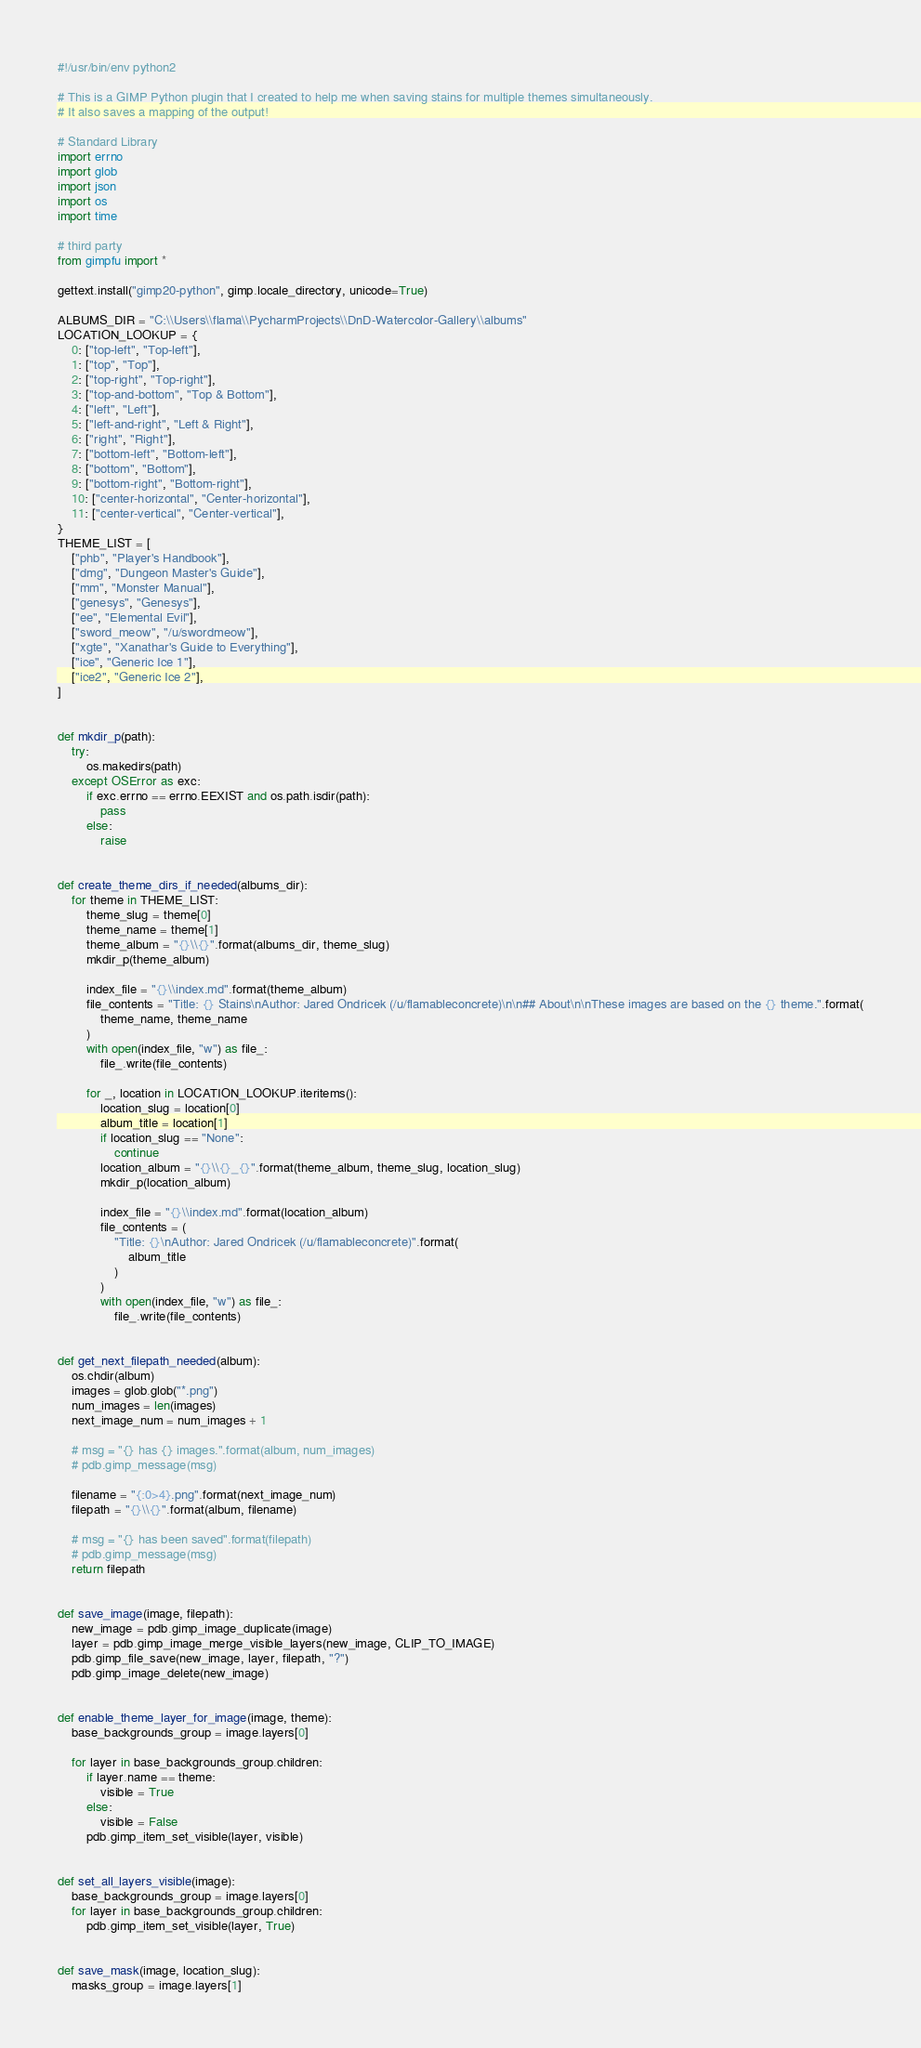<code> <loc_0><loc_0><loc_500><loc_500><_Python_>#!/usr/bin/env python2

# This is a GIMP Python plugin that I created to help me when saving stains for multiple themes simultaneously.
# It also saves a mapping of the output!

# Standard Library
import errno
import glob
import json
import os
import time

# third party
from gimpfu import *

gettext.install("gimp20-python", gimp.locale_directory, unicode=True)

ALBUMS_DIR = "C:\\Users\\flama\\PycharmProjects\\DnD-Watercolor-Gallery\\albums"
LOCATION_LOOKUP = {
    0: ["top-left", "Top-left"],
    1: ["top", "Top"],
    2: ["top-right", "Top-right"],
    3: ["top-and-bottom", "Top & Bottom"],
    4: ["left", "Left"],
    5: ["left-and-right", "Left & Right"],
    6: ["right", "Right"],
    7: ["bottom-left", "Bottom-left"],
    8: ["bottom", "Bottom"],
    9: ["bottom-right", "Bottom-right"],
    10: ["center-horizontal", "Center-horizontal"],
    11: ["center-vertical", "Center-vertical"],
}
THEME_LIST = [
    ["phb", "Player's Handbook"],
    ["dmg", "Dungeon Master's Guide"],
    ["mm", "Monster Manual"],
    ["genesys", "Genesys"],
    ["ee", "Elemental Evil"],
    ["sword_meow", "/u/swordmeow"],
    ["xgte", "Xanathar's Guide to Everything"],
    ["ice", "Generic Ice 1"],
    ["ice2", "Generic Ice 2"],
]


def mkdir_p(path):
    try:
        os.makedirs(path)
    except OSError as exc:
        if exc.errno == errno.EEXIST and os.path.isdir(path):
            pass
        else:
            raise


def create_theme_dirs_if_needed(albums_dir):
    for theme in THEME_LIST:
        theme_slug = theme[0]
        theme_name = theme[1]
        theme_album = "{}\\{}".format(albums_dir, theme_slug)
        mkdir_p(theme_album)

        index_file = "{}\\index.md".format(theme_album)
        file_contents = "Title: {} Stains\nAuthor: Jared Ondricek (/u/flamableconcrete)\n\n## About\n\nThese images are based on the {} theme.".format(
            theme_name, theme_name
        )
        with open(index_file, "w") as file_:
            file_.write(file_contents)

        for _, location in LOCATION_LOOKUP.iteritems():
            location_slug = location[0]
            album_title = location[1]
            if location_slug == "None":
                continue
            location_album = "{}\\{}_{}".format(theme_album, theme_slug, location_slug)
            mkdir_p(location_album)

            index_file = "{}\\index.md".format(location_album)
            file_contents = (
                "Title: {}\nAuthor: Jared Ondricek (/u/flamableconcrete)".format(
                    album_title
                )
            )
            with open(index_file, "w") as file_:
                file_.write(file_contents)


def get_next_filepath_needed(album):
    os.chdir(album)
    images = glob.glob("*.png")
    num_images = len(images)
    next_image_num = num_images + 1

    # msg = "{} has {} images.".format(album, num_images)
    # pdb.gimp_message(msg)

    filename = "{:0>4}.png".format(next_image_num)
    filepath = "{}\\{}".format(album, filename)

    # msg = "{} has been saved".format(filepath)
    # pdb.gimp_message(msg)
    return filepath


def save_image(image, filepath):
    new_image = pdb.gimp_image_duplicate(image)
    layer = pdb.gimp_image_merge_visible_layers(new_image, CLIP_TO_IMAGE)
    pdb.gimp_file_save(new_image, layer, filepath, "?")
    pdb.gimp_image_delete(new_image)


def enable_theme_layer_for_image(image, theme):
    base_backgrounds_group = image.layers[0]

    for layer in base_backgrounds_group.children:
        if layer.name == theme:
            visible = True
        else:
            visible = False
        pdb.gimp_item_set_visible(layer, visible)


def set_all_layers_visible(image):
    base_backgrounds_group = image.layers[0]
    for layer in base_backgrounds_group.children:
        pdb.gimp_item_set_visible(layer, True)


def save_mask(image, location_slug):
    masks_group = image.layers[1]</code> 